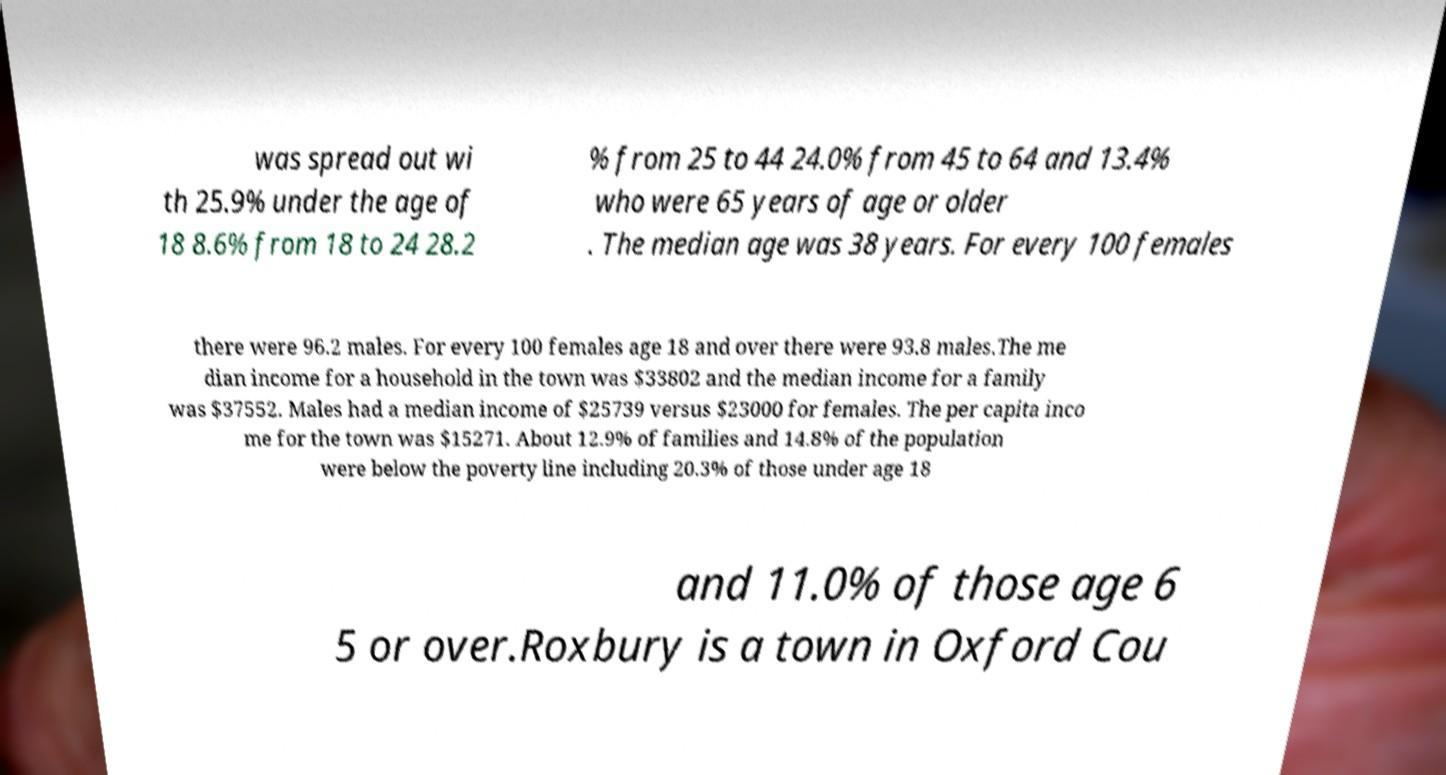Please read and relay the text visible in this image. What does it say? was spread out wi th 25.9% under the age of 18 8.6% from 18 to 24 28.2 % from 25 to 44 24.0% from 45 to 64 and 13.4% who were 65 years of age or older . The median age was 38 years. For every 100 females there were 96.2 males. For every 100 females age 18 and over there were 93.8 males.The me dian income for a household in the town was $33802 and the median income for a family was $37552. Males had a median income of $25739 versus $23000 for females. The per capita inco me for the town was $15271. About 12.9% of families and 14.8% of the population were below the poverty line including 20.3% of those under age 18 and 11.0% of those age 6 5 or over.Roxbury is a town in Oxford Cou 